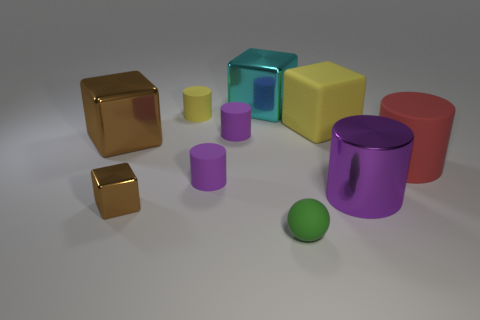Subtract all brown spheres. How many purple cylinders are left? 3 Subtract all yellow cylinders. How many cylinders are left? 4 Subtract all red cylinders. How many cylinders are left? 4 Subtract 1 blocks. How many blocks are left? 3 Subtract all cyan cylinders. Subtract all green balls. How many cylinders are left? 5 Subtract all spheres. How many objects are left? 9 Add 4 blocks. How many blocks are left? 8 Add 4 tiny red cubes. How many tiny red cubes exist? 4 Subtract 1 green spheres. How many objects are left? 9 Subtract all brown metallic objects. Subtract all yellow cubes. How many objects are left? 7 